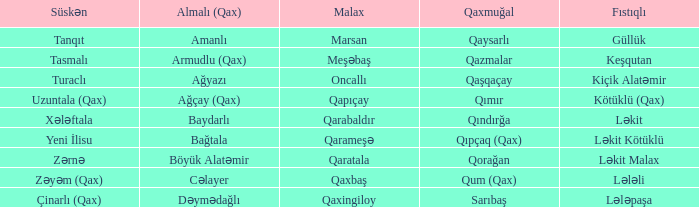What is the Qaxmuğal village with a Fistiqli village keşqutan? Qazmalar. 